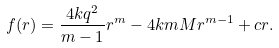<formula> <loc_0><loc_0><loc_500><loc_500>f ( r ) = \frac { 4 k q ^ { 2 } } { m - 1 } r ^ { m } - 4 k m M r ^ { m - 1 } + c r .</formula> 